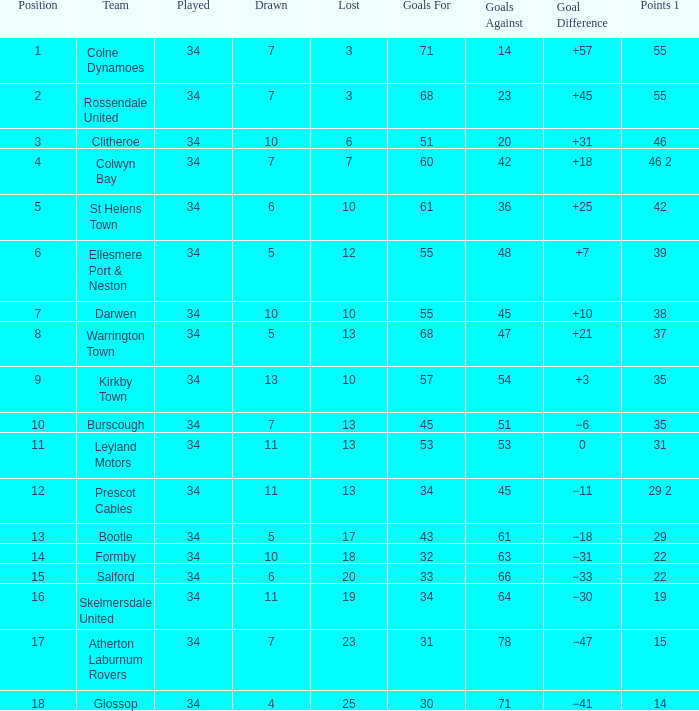In which position are there 47 goals against and more than 34 games played? None. 